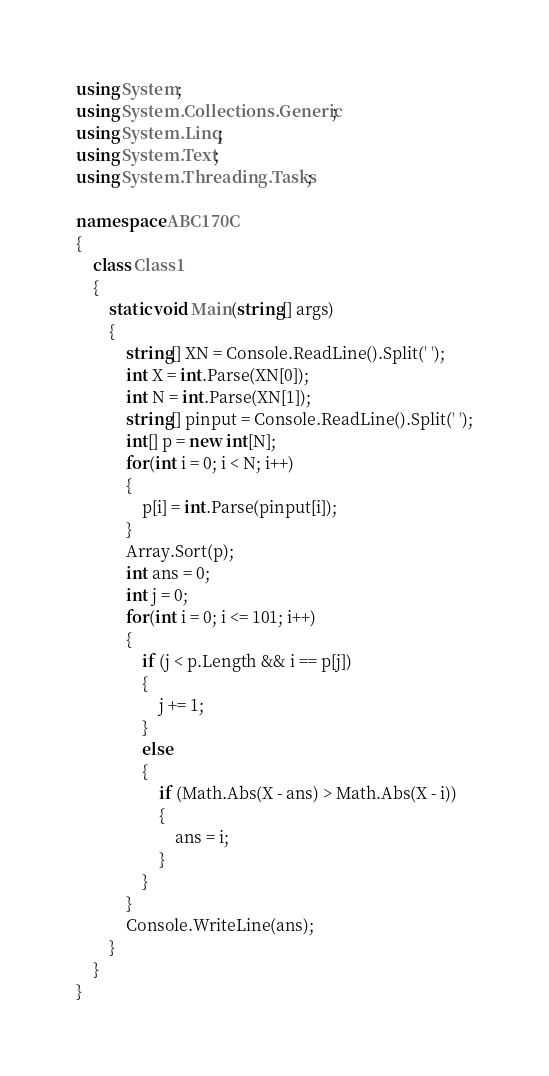<code> <loc_0><loc_0><loc_500><loc_500><_C#_>using System;
using System.Collections.Generic;
using System.Linq;
using System.Text;
using System.Threading.Tasks;

namespace ABC170C
{
    class Class1
    {
        static void Main(string[] args)
        {
            string[] XN = Console.ReadLine().Split(' ');
            int X = int.Parse(XN[0]);
            int N = int.Parse(XN[1]);
            string[] pinput = Console.ReadLine().Split(' ');
            int[] p = new int[N];
            for(int i = 0; i < N; i++)
            {
                p[i] = int.Parse(pinput[i]);
            }
            Array.Sort(p);
            int ans = 0;
            int j = 0;
            for(int i = 0; i <= 101; i++)
            {
                if (j < p.Length && i == p[j])
                {
                    j += 1;
                }
                else
                {
                    if (Math.Abs(X - ans) > Math.Abs(X - i))
                    {
                        ans = i;
                    }
                }
            }
            Console.WriteLine(ans);
        }
    }
}
</code> 